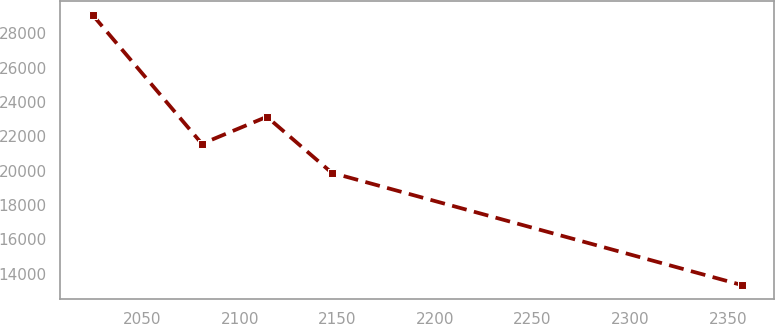Convert chart. <chart><loc_0><loc_0><loc_500><loc_500><line_chart><ecel><fcel>Unnamed: 1<nl><fcel>2024.59<fcel>29067.1<nl><fcel>2080.65<fcel>21558.3<nl><fcel>2113.91<fcel>23131.4<nl><fcel>2147.17<fcel>19869.1<nl><fcel>2357.15<fcel>13335.6<nl></chart> 